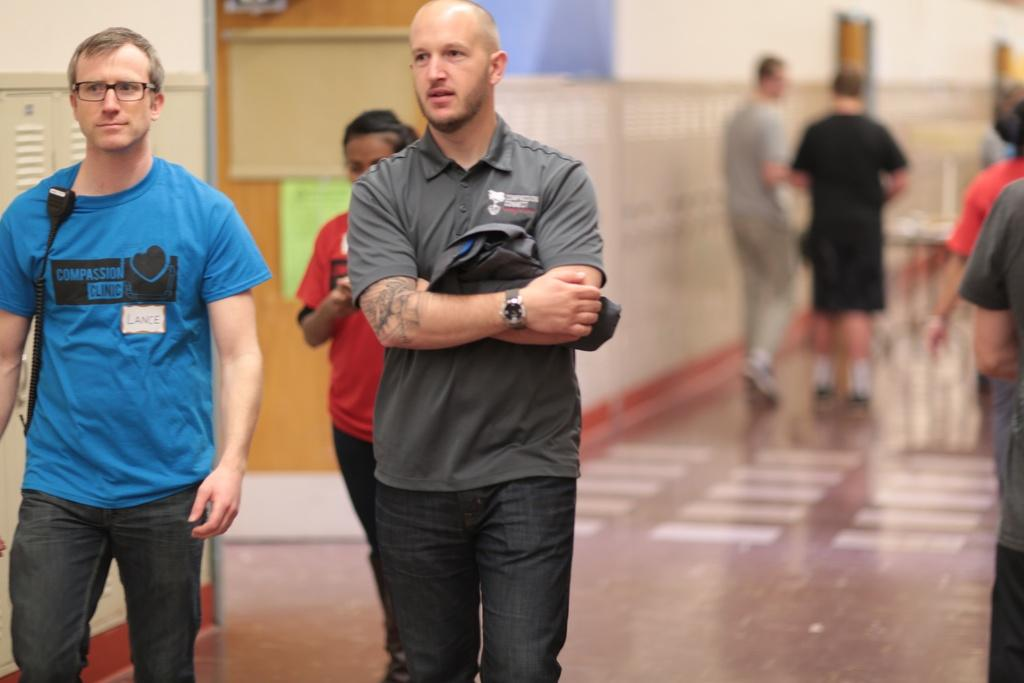How many people are in the image? There are persons in the image, but the exact number cannot be determined from the provided facts. What is located in the background of the image? There is a door, boards, a wall, and rods in the background of the image. What part of the image is visible at the bottom? The floor is visible at the bottom of the image. What type of pen is being used by the person in the image? There is no pen present in the image, and therefore no such activity can be observed. 